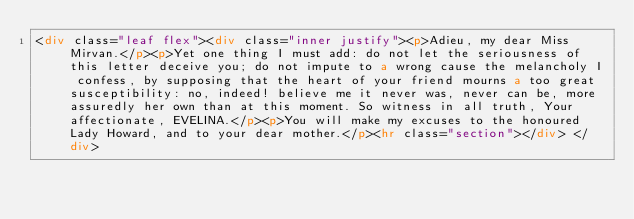Convert code to text. <code><loc_0><loc_0><loc_500><loc_500><_HTML_><div class="leaf flex"><div class="inner justify"><p>Adieu, my dear Miss Mirvan.</p><p>Yet one thing I must add: do not let the seriousness of this letter deceive you; do not impute to a wrong cause the melancholy I confess, by supposing that the heart of your friend mourns a too great susceptibility: no, indeed! believe me it never was, never can be, more assuredly her own than at this moment. So witness in all truth, Your affectionate, EVELINA.</p><p>You will make my excuses to the honoured Lady Howard, and to your dear mother.</p><hr class="section"></div> </div></code> 